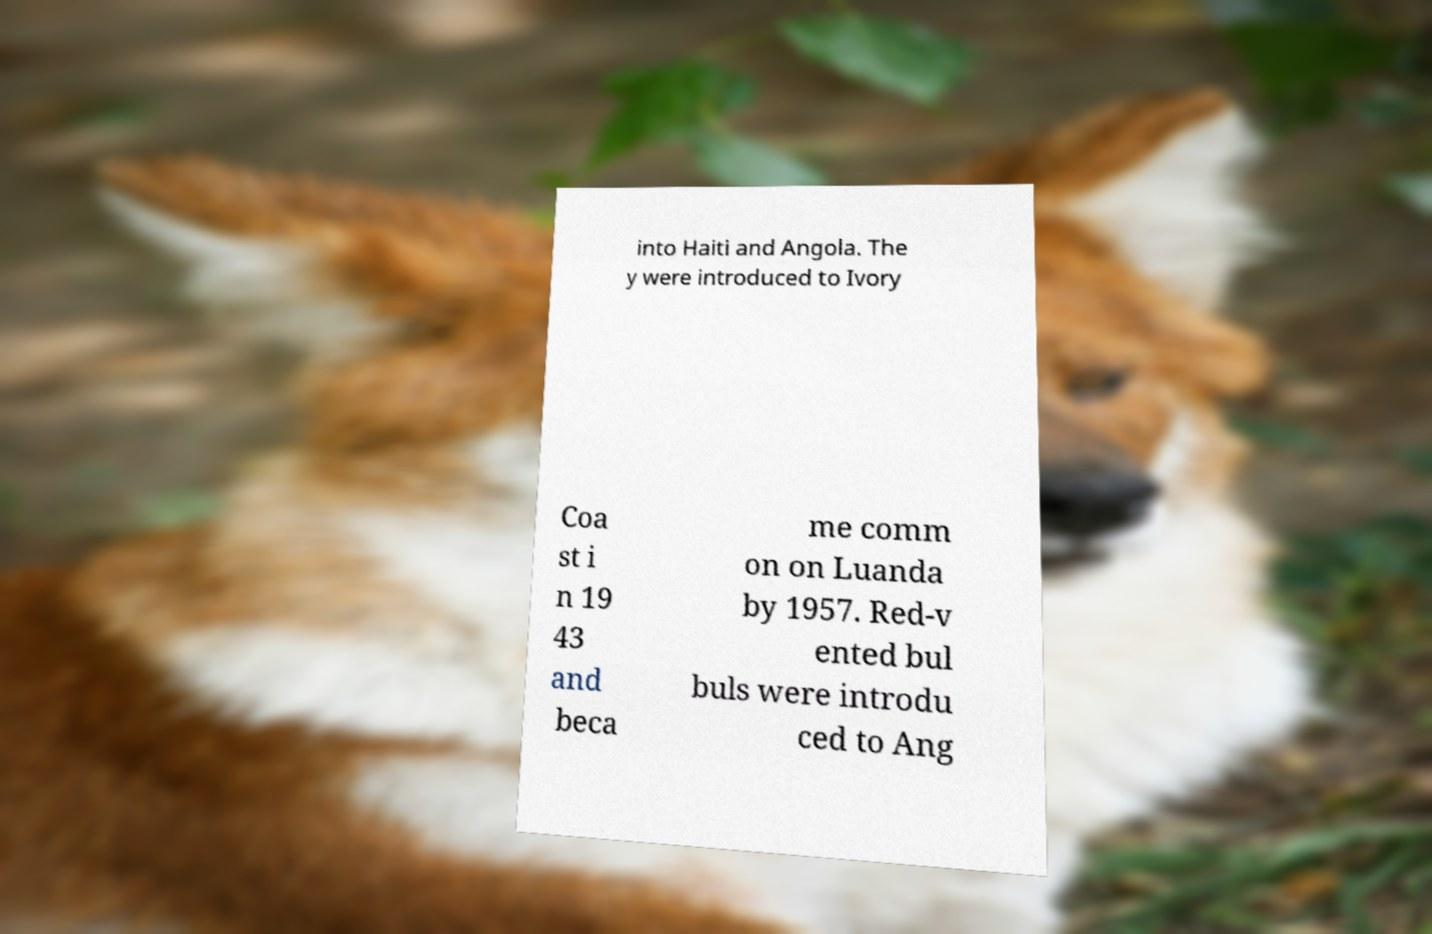Can you accurately transcribe the text from the provided image for me? into Haiti and Angola. The y were introduced to Ivory Coa st i n 19 43 and beca me comm on on Luanda by 1957. Red-v ented bul buls were introdu ced to Ang 